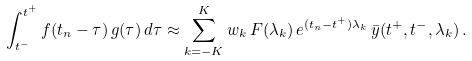Convert formula to latex. <formula><loc_0><loc_0><loc_500><loc_500>\int _ { t ^ { - } } ^ { t ^ { + } } f ( t _ { n } - \tau ) \, g ( \tau ) \, d \tau \approx \sum _ { k = - K } ^ { K } w _ { k } \, F ( \lambda _ { k } ) \, e ^ { ( t _ { n } - t ^ { + } ) \lambda _ { k } } \, \bar { y } ( t ^ { + } , t ^ { - } , \lambda _ { k } ) \, .</formula> 